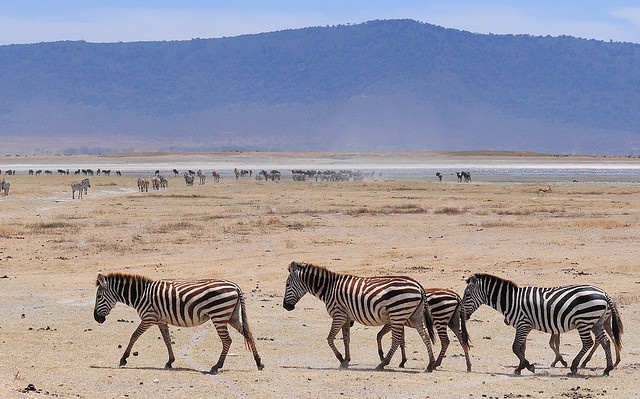Describe the objects in this image and their specific colors. I can see zebra in lightblue, black, gray, maroon, and darkgray tones, zebra in lightblue, black, gray, darkgray, and lightgray tones, zebra in lightblue, black, gray, maroon, and darkgray tones, zebra in lightblue, black, gray, and maroon tones, and zebra in lightblue, gray, and darkgray tones in this image. 